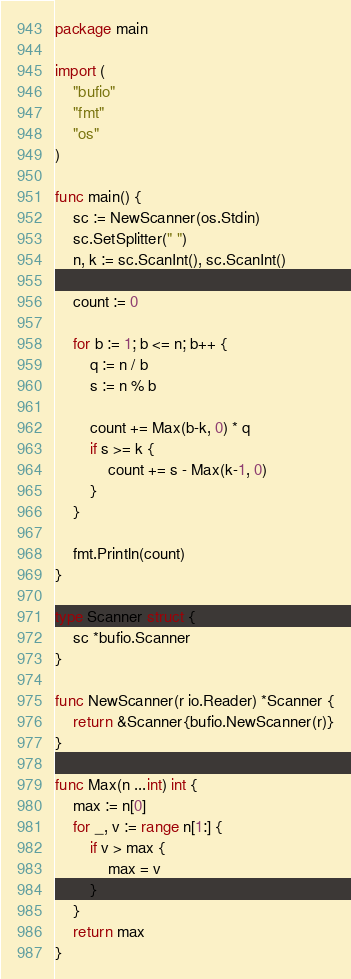Convert code to text. <code><loc_0><loc_0><loc_500><loc_500><_Go_>package main

import (
	"bufio"
	"fmt"
	"os"
)

func main() {
	sc := NewScanner(os.Stdin)
	sc.SetSplitter(" ")
	n, k := sc.ScanInt(), sc.ScanInt()

	count := 0

	for b := 1; b <= n; b++ {
		q := n / b
		s := n % b

		count += Max(b-k, 0) * q
		if s >= k {
			count += s - Max(k-1, 0)
		}
	}

	fmt.Println(count)
}

type Scanner struct {
	sc *bufio.Scanner
}

func NewScanner(r io.Reader) *Scanner {
	return &Scanner{bufio.NewScanner(r)}
}

func Max(n ...int) int {
	max := n[0]
	for _, v := range n[1:] {
		if v > max {
			max = v
		}
	}
	return max
}
</code> 